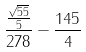<formula> <loc_0><loc_0><loc_500><loc_500>\frac { \frac { \sqrt { 5 5 } } { 5 } } { 2 7 8 } - \frac { 1 4 5 } { 4 }</formula> 